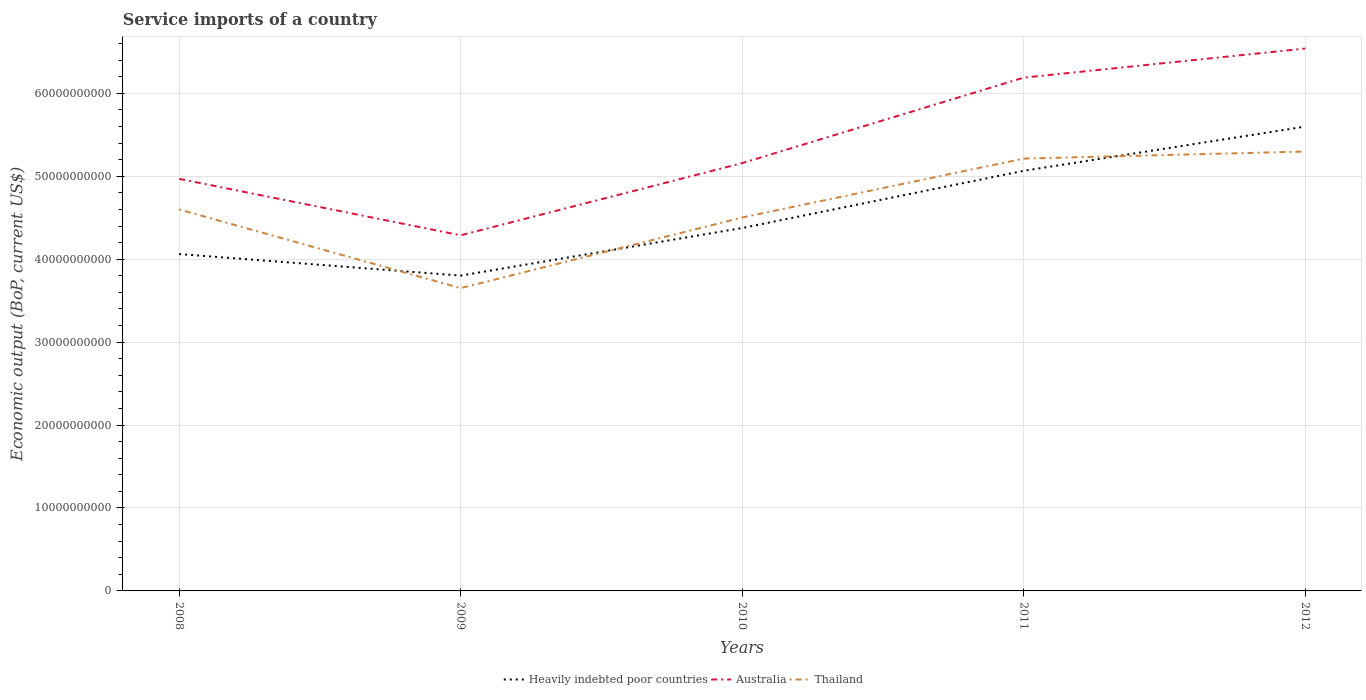How many different coloured lines are there?
Ensure brevity in your answer.  3. Does the line corresponding to Thailand intersect with the line corresponding to Heavily indebted poor countries?
Offer a terse response. Yes. Is the number of lines equal to the number of legend labels?
Your answer should be very brief. Yes. Across all years, what is the maximum service imports in Thailand?
Offer a very short reply. 3.65e+1. In which year was the service imports in Heavily indebted poor countries maximum?
Make the answer very short. 2009. What is the total service imports in Heavily indebted poor countries in the graph?
Give a very brief answer. -5.33e+09. What is the difference between the highest and the second highest service imports in Australia?
Make the answer very short. 2.25e+1. How many lines are there?
Give a very brief answer. 3. Are the values on the major ticks of Y-axis written in scientific E-notation?
Make the answer very short. No. Does the graph contain any zero values?
Give a very brief answer. No. Where does the legend appear in the graph?
Provide a short and direct response. Bottom center. How many legend labels are there?
Offer a terse response. 3. What is the title of the graph?
Keep it short and to the point. Service imports of a country. What is the label or title of the X-axis?
Provide a succinct answer. Years. What is the label or title of the Y-axis?
Keep it short and to the point. Economic output (BoP, current US$). What is the Economic output (BoP, current US$) in Heavily indebted poor countries in 2008?
Keep it short and to the point. 4.06e+1. What is the Economic output (BoP, current US$) in Australia in 2008?
Provide a short and direct response. 4.97e+1. What is the Economic output (BoP, current US$) of Thailand in 2008?
Keep it short and to the point. 4.60e+1. What is the Economic output (BoP, current US$) of Heavily indebted poor countries in 2009?
Your response must be concise. 3.80e+1. What is the Economic output (BoP, current US$) of Australia in 2009?
Offer a terse response. 4.29e+1. What is the Economic output (BoP, current US$) of Thailand in 2009?
Offer a terse response. 3.65e+1. What is the Economic output (BoP, current US$) of Heavily indebted poor countries in 2010?
Keep it short and to the point. 4.38e+1. What is the Economic output (BoP, current US$) of Australia in 2010?
Keep it short and to the point. 5.16e+1. What is the Economic output (BoP, current US$) of Thailand in 2010?
Provide a succinct answer. 4.50e+1. What is the Economic output (BoP, current US$) in Heavily indebted poor countries in 2011?
Ensure brevity in your answer.  5.07e+1. What is the Economic output (BoP, current US$) of Australia in 2011?
Give a very brief answer. 6.19e+1. What is the Economic output (BoP, current US$) of Thailand in 2011?
Provide a short and direct response. 5.21e+1. What is the Economic output (BoP, current US$) in Heavily indebted poor countries in 2012?
Keep it short and to the point. 5.60e+1. What is the Economic output (BoP, current US$) in Australia in 2012?
Your response must be concise. 6.54e+1. What is the Economic output (BoP, current US$) in Thailand in 2012?
Offer a very short reply. 5.30e+1. Across all years, what is the maximum Economic output (BoP, current US$) of Heavily indebted poor countries?
Your answer should be compact. 5.60e+1. Across all years, what is the maximum Economic output (BoP, current US$) in Australia?
Offer a very short reply. 6.54e+1. Across all years, what is the maximum Economic output (BoP, current US$) of Thailand?
Provide a succinct answer. 5.30e+1. Across all years, what is the minimum Economic output (BoP, current US$) of Heavily indebted poor countries?
Give a very brief answer. 3.80e+1. Across all years, what is the minimum Economic output (BoP, current US$) in Australia?
Keep it short and to the point. 4.29e+1. Across all years, what is the minimum Economic output (BoP, current US$) of Thailand?
Your response must be concise. 3.65e+1. What is the total Economic output (BoP, current US$) in Heavily indebted poor countries in the graph?
Your answer should be compact. 2.29e+11. What is the total Economic output (BoP, current US$) of Australia in the graph?
Your answer should be very brief. 2.71e+11. What is the total Economic output (BoP, current US$) of Thailand in the graph?
Offer a terse response. 2.33e+11. What is the difference between the Economic output (BoP, current US$) in Heavily indebted poor countries in 2008 and that in 2009?
Your response must be concise. 2.60e+09. What is the difference between the Economic output (BoP, current US$) of Australia in 2008 and that in 2009?
Your response must be concise. 6.80e+09. What is the difference between the Economic output (BoP, current US$) of Thailand in 2008 and that in 2009?
Offer a very short reply. 9.49e+09. What is the difference between the Economic output (BoP, current US$) of Heavily indebted poor countries in 2008 and that in 2010?
Ensure brevity in your answer.  -3.14e+09. What is the difference between the Economic output (BoP, current US$) of Australia in 2008 and that in 2010?
Offer a very short reply. -1.90e+09. What is the difference between the Economic output (BoP, current US$) in Thailand in 2008 and that in 2010?
Provide a short and direct response. 9.72e+08. What is the difference between the Economic output (BoP, current US$) of Heavily indebted poor countries in 2008 and that in 2011?
Offer a very short reply. -1.00e+1. What is the difference between the Economic output (BoP, current US$) of Australia in 2008 and that in 2011?
Offer a very short reply. -1.22e+1. What is the difference between the Economic output (BoP, current US$) in Thailand in 2008 and that in 2011?
Offer a very short reply. -6.13e+09. What is the difference between the Economic output (BoP, current US$) in Heavily indebted poor countries in 2008 and that in 2012?
Your answer should be compact. -1.54e+1. What is the difference between the Economic output (BoP, current US$) in Australia in 2008 and that in 2012?
Make the answer very short. -1.57e+1. What is the difference between the Economic output (BoP, current US$) of Thailand in 2008 and that in 2012?
Your answer should be compact. -6.98e+09. What is the difference between the Economic output (BoP, current US$) in Heavily indebted poor countries in 2009 and that in 2010?
Offer a very short reply. -5.74e+09. What is the difference between the Economic output (BoP, current US$) of Australia in 2009 and that in 2010?
Your response must be concise. -8.70e+09. What is the difference between the Economic output (BoP, current US$) in Thailand in 2009 and that in 2010?
Keep it short and to the point. -8.51e+09. What is the difference between the Economic output (BoP, current US$) of Heavily indebted poor countries in 2009 and that in 2011?
Your answer should be compact. -1.26e+1. What is the difference between the Economic output (BoP, current US$) of Australia in 2009 and that in 2011?
Make the answer very short. -1.90e+1. What is the difference between the Economic output (BoP, current US$) of Thailand in 2009 and that in 2011?
Keep it short and to the point. -1.56e+1. What is the difference between the Economic output (BoP, current US$) in Heavily indebted poor countries in 2009 and that in 2012?
Provide a succinct answer. -1.80e+1. What is the difference between the Economic output (BoP, current US$) in Australia in 2009 and that in 2012?
Make the answer very short. -2.25e+1. What is the difference between the Economic output (BoP, current US$) in Thailand in 2009 and that in 2012?
Your answer should be very brief. -1.65e+1. What is the difference between the Economic output (BoP, current US$) in Heavily indebted poor countries in 2010 and that in 2011?
Provide a short and direct response. -6.90e+09. What is the difference between the Economic output (BoP, current US$) of Australia in 2010 and that in 2011?
Your response must be concise. -1.03e+1. What is the difference between the Economic output (BoP, current US$) of Thailand in 2010 and that in 2011?
Your answer should be very brief. -7.11e+09. What is the difference between the Economic output (BoP, current US$) in Heavily indebted poor countries in 2010 and that in 2012?
Provide a succinct answer. -1.22e+1. What is the difference between the Economic output (BoP, current US$) in Australia in 2010 and that in 2012?
Make the answer very short. -1.38e+1. What is the difference between the Economic output (BoP, current US$) of Thailand in 2010 and that in 2012?
Provide a succinct answer. -7.96e+09. What is the difference between the Economic output (BoP, current US$) in Heavily indebted poor countries in 2011 and that in 2012?
Provide a succinct answer. -5.33e+09. What is the difference between the Economic output (BoP, current US$) of Australia in 2011 and that in 2012?
Offer a very short reply. -3.51e+09. What is the difference between the Economic output (BoP, current US$) in Thailand in 2011 and that in 2012?
Ensure brevity in your answer.  -8.51e+08. What is the difference between the Economic output (BoP, current US$) of Heavily indebted poor countries in 2008 and the Economic output (BoP, current US$) of Australia in 2009?
Provide a short and direct response. -2.26e+09. What is the difference between the Economic output (BoP, current US$) of Heavily indebted poor countries in 2008 and the Economic output (BoP, current US$) of Thailand in 2009?
Offer a terse response. 4.11e+09. What is the difference between the Economic output (BoP, current US$) in Australia in 2008 and the Economic output (BoP, current US$) in Thailand in 2009?
Provide a succinct answer. 1.32e+1. What is the difference between the Economic output (BoP, current US$) in Heavily indebted poor countries in 2008 and the Economic output (BoP, current US$) in Australia in 2010?
Ensure brevity in your answer.  -1.10e+1. What is the difference between the Economic output (BoP, current US$) of Heavily indebted poor countries in 2008 and the Economic output (BoP, current US$) of Thailand in 2010?
Ensure brevity in your answer.  -4.40e+09. What is the difference between the Economic output (BoP, current US$) of Australia in 2008 and the Economic output (BoP, current US$) of Thailand in 2010?
Offer a terse response. 4.66e+09. What is the difference between the Economic output (BoP, current US$) of Heavily indebted poor countries in 2008 and the Economic output (BoP, current US$) of Australia in 2011?
Give a very brief answer. -2.13e+1. What is the difference between the Economic output (BoP, current US$) of Heavily indebted poor countries in 2008 and the Economic output (BoP, current US$) of Thailand in 2011?
Your response must be concise. -1.15e+1. What is the difference between the Economic output (BoP, current US$) in Australia in 2008 and the Economic output (BoP, current US$) in Thailand in 2011?
Your answer should be compact. -2.44e+09. What is the difference between the Economic output (BoP, current US$) of Heavily indebted poor countries in 2008 and the Economic output (BoP, current US$) of Australia in 2012?
Your answer should be very brief. -2.48e+1. What is the difference between the Economic output (BoP, current US$) in Heavily indebted poor countries in 2008 and the Economic output (BoP, current US$) in Thailand in 2012?
Give a very brief answer. -1.24e+1. What is the difference between the Economic output (BoP, current US$) of Australia in 2008 and the Economic output (BoP, current US$) of Thailand in 2012?
Give a very brief answer. -3.29e+09. What is the difference between the Economic output (BoP, current US$) in Heavily indebted poor countries in 2009 and the Economic output (BoP, current US$) in Australia in 2010?
Make the answer very short. -1.36e+1. What is the difference between the Economic output (BoP, current US$) of Heavily indebted poor countries in 2009 and the Economic output (BoP, current US$) of Thailand in 2010?
Keep it short and to the point. -7.00e+09. What is the difference between the Economic output (BoP, current US$) of Australia in 2009 and the Economic output (BoP, current US$) of Thailand in 2010?
Your response must be concise. -2.14e+09. What is the difference between the Economic output (BoP, current US$) of Heavily indebted poor countries in 2009 and the Economic output (BoP, current US$) of Australia in 2011?
Give a very brief answer. -2.39e+1. What is the difference between the Economic output (BoP, current US$) of Heavily indebted poor countries in 2009 and the Economic output (BoP, current US$) of Thailand in 2011?
Keep it short and to the point. -1.41e+1. What is the difference between the Economic output (BoP, current US$) of Australia in 2009 and the Economic output (BoP, current US$) of Thailand in 2011?
Your answer should be very brief. -9.25e+09. What is the difference between the Economic output (BoP, current US$) of Heavily indebted poor countries in 2009 and the Economic output (BoP, current US$) of Australia in 2012?
Provide a short and direct response. -2.74e+1. What is the difference between the Economic output (BoP, current US$) in Heavily indebted poor countries in 2009 and the Economic output (BoP, current US$) in Thailand in 2012?
Your answer should be very brief. -1.50e+1. What is the difference between the Economic output (BoP, current US$) in Australia in 2009 and the Economic output (BoP, current US$) in Thailand in 2012?
Keep it short and to the point. -1.01e+1. What is the difference between the Economic output (BoP, current US$) of Heavily indebted poor countries in 2010 and the Economic output (BoP, current US$) of Australia in 2011?
Keep it short and to the point. -1.81e+1. What is the difference between the Economic output (BoP, current US$) in Heavily indebted poor countries in 2010 and the Economic output (BoP, current US$) in Thailand in 2011?
Make the answer very short. -8.37e+09. What is the difference between the Economic output (BoP, current US$) of Australia in 2010 and the Economic output (BoP, current US$) of Thailand in 2011?
Your answer should be compact. -5.46e+08. What is the difference between the Economic output (BoP, current US$) of Heavily indebted poor countries in 2010 and the Economic output (BoP, current US$) of Australia in 2012?
Give a very brief answer. -2.16e+1. What is the difference between the Economic output (BoP, current US$) in Heavily indebted poor countries in 2010 and the Economic output (BoP, current US$) in Thailand in 2012?
Offer a very short reply. -9.22e+09. What is the difference between the Economic output (BoP, current US$) of Australia in 2010 and the Economic output (BoP, current US$) of Thailand in 2012?
Offer a terse response. -1.40e+09. What is the difference between the Economic output (BoP, current US$) in Heavily indebted poor countries in 2011 and the Economic output (BoP, current US$) in Australia in 2012?
Ensure brevity in your answer.  -1.47e+1. What is the difference between the Economic output (BoP, current US$) in Heavily indebted poor countries in 2011 and the Economic output (BoP, current US$) in Thailand in 2012?
Your answer should be very brief. -2.32e+09. What is the difference between the Economic output (BoP, current US$) of Australia in 2011 and the Economic output (BoP, current US$) of Thailand in 2012?
Your answer should be compact. 8.91e+09. What is the average Economic output (BoP, current US$) of Heavily indebted poor countries per year?
Your answer should be compact. 4.58e+1. What is the average Economic output (BoP, current US$) in Australia per year?
Your answer should be very brief. 5.43e+1. What is the average Economic output (BoP, current US$) of Thailand per year?
Ensure brevity in your answer.  4.65e+1. In the year 2008, what is the difference between the Economic output (BoP, current US$) in Heavily indebted poor countries and Economic output (BoP, current US$) in Australia?
Give a very brief answer. -9.07e+09. In the year 2008, what is the difference between the Economic output (BoP, current US$) of Heavily indebted poor countries and Economic output (BoP, current US$) of Thailand?
Your answer should be very brief. -5.38e+09. In the year 2008, what is the difference between the Economic output (BoP, current US$) of Australia and Economic output (BoP, current US$) of Thailand?
Provide a succinct answer. 3.69e+09. In the year 2009, what is the difference between the Economic output (BoP, current US$) in Heavily indebted poor countries and Economic output (BoP, current US$) in Australia?
Your answer should be very brief. -4.86e+09. In the year 2009, what is the difference between the Economic output (BoP, current US$) in Heavily indebted poor countries and Economic output (BoP, current US$) in Thailand?
Keep it short and to the point. 1.51e+09. In the year 2009, what is the difference between the Economic output (BoP, current US$) in Australia and Economic output (BoP, current US$) in Thailand?
Your answer should be very brief. 6.37e+09. In the year 2010, what is the difference between the Economic output (BoP, current US$) in Heavily indebted poor countries and Economic output (BoP, current US$) in Australia?
Provide a short and direct response. -7.83e+09. In the year 2010, what is the difference between the Economic output (BoP, current US$) of Heavily indebted poor countries and Economic output (BoP, current US$) of Thailand?
Your answer should be very brief. -1.27e+09. In the year 2010, what is the difference between the Economic output (BoP, current US$) of Australia and Economic output (BoP, current US$) of Thailand?
Give a very brief answer. 6.56e+09. In the year 2011, what is the difference between the Economic output (BoP, current US$) in Heavily indebted poor countries and Economic output (BoP, current US$) in Australia?
Offer a very short reply. -1.12e+1. In the year 2011, what is the difference between the Economic output (BoP, current US$) of Heavily indebted poor countries and Economic output (BoP, current US$) of Thailand?
Give a very brief answer. -1.47e+09. In the year 2011, what is the difference between the Economic output (BoP, current US$) in Australia and Economic output (BoP, current US$) in Thailand?
Your response must be concise. 9.76e+09. In the year 2012, what is the difference between the Economic output (BoP, current US$) in Heavily indebted poor countries and Economic output (BoP, current US$) in Australia?
Provide a succinct answer. -9.41e+09. In the year 2012, what is the difference between the Economic output (BoP, current US$) in Heavily indebted poor countries and Economic output (BoP, current US$) in Thailand?
Your answer should be very brief. 3.01e+09. In the year 2012, what is the difference between the Economic output (BoP, current US$) of Australia and Economic output (BoP, current US$) of Thailand?
Give a very brief answer. 1.24e+1. What is the ratio of the Economic output (BoP, current US$) in Heavily indebted poor countries in 2008 to that in 2009?
Ensure brevity in your answer.  1.07. What is the ratio of the Economic output (BoP, current US$) in Australia in 2008 to that in 2009?
Your response must be concise. 1.16. What is the ratio of the Economic output (BoP, current US$) of Thailand in 2008 to that in 2009?
Make the answer very short. 1.26. What is the ratio of the Economic output (BoP, current US$) in Heavily indebted poor countries in 2008 to that in 2010?
Provide a succinct answer. 0.93. What is the ratio of the Economic output (BoP, current US$) of Australia in 2008 to that in 2010?
Your answer should be very brief. 0.96. What is the ratio of the Economic output (BoP, current US$) of Thailand in 2008 to that in 2010?
Provide a short and direct response. 1.02. What is the ratio of the Economic output (BoP, current US$) of Heavily indebted poor countries in 2008 to that in 2011?
Your answer should be compact. 0.8. What is the ratio of the Economic output (BoP, current US$) of Australia in 2008 to that in 2011?
Provide a short and direct response. 0.8. What is the ratio of the Economic output (BoP, current US$) in Thailand in 2008 to that in 2011?
Provide a succinct answer. 0.88. What is the ratio of the Economic output (BoP, current US$) in Heavily indebted poor countries in 2008 to that in 2012?
Provide a succinct answer. 0.73. What is the ratio of the Economic output (BoP, current US$) in Australia in 2008 to that in 2012?
Your response must be concise. 0.76. What is the ratio of the Economic output (BoP, current US$) of Thailand in 2008 to that in 2012?
Provide a short and direct response. 0.87. What is the ratio of the Economic output (BoP, current US$) in Heavily indebted poor countries in 2009 to that in 2010?
Offer a terse response. 0.87. What is the ratio of the Economic output (BoP, current US$) in Australia in 2009 to that in 2010?
Give a very brief answer. 0.83. What is the ratio of the Economic output (BoP, current US$) in Thailand in 2009 to that in 2010?
Ensure brevity in your answer.  0.81. What is the ratio of the Economic output (BoP, current US$) of Heavily indebted poor countries in 2009 to that in 2011?
Give a very brief answer. 0.75. What is the ratio of the Economic output (BoP, current US$) of Australia in 2009 to that in 2011?
Ensure brevity in your answer.  0.69. What is the ratio of the Economic output (BoP, current US$) in Thailand in 2009 to that in 2011?
Offer a terse response. 0.7. What is the ratio of the Economic output (BoP, current US$) of Heavily indebted poor countries in 2009 to that in 2012?
Provide a short and direct response. 0.68. What is the ratio of the Economic output (BoP, current US$) of Australia in 2009 to that in 2012?
Keep it short and to the point. 0.66. What is the ratio of the Economic output (BoP, current US$) of Thailand in 2009 to that in 2012?
Make the answer very short. 0.69. What is the ratio of the Economic output (BoP, current US$) in Heavily indebted poor countries in 2010 to that in 2011?
Provide a succinct answer. 0.86. What is the ratio of the Economic output (BoP, current US$) of Australia in 2010 to that in 2011?
Your answer should be compact. 0.83. What is the ratio of the Economic output (BoP, current US$) of Thailand in 2010 to that in 2011?
Provide a succinct answer. 0.86. What is the ratio of the Economic output (BoP, current US$) of Heavily indebted poor countries in 2010 to that in 2012?
Your response must be concise. 0.78. What is the ratio of the Economic output (BoP, current US$) in Australia in 2010 to that in 2012?
Make the answer very short. 0.79. What is the ratio of the Economic output (BoP, current US$) of Thailand in 2010 to that in 2012?
Your answer should be compact. 0.85. What is the ratio of the Economic output (BoP, current US$) in Heavily indebted poor countries in 2011 to that in 2012?
Make the answer very short. 0.9. What is the ratio of the Economic output (BoP, current US$) in Australia in 2011 to that in 2012?
Keep it short and to the point. 0.95. What is the ratio of the Economic output (BoP, current US$) of Thailand in 2011 to that in 2012?
Give a very brief answer. 0.98. What is the difference between the highest and the second highest Economic output (BoP, current US$) of Heavily indebted poor countries?
Offer a terse response. 5.33e+09. What is the difference between the highest and the second highest Economic output (BoP, current US$) in Australia?
Provide a short and direct response. 3.51e+09. What is the difference between the highest and the second highest Economic output (BoP, current US$) in Thailand?
Offer a terse response. 8.51e+08. What is the difference between the highest and the lowest Economic output (BoP, current US$) of Heavily indebted poor countries?
Ensure brevity in your answer.  1.80e+1. What is the difference between the highest and the lowest Economic output (BoP, current US$) of Australia?
Offer a terse response. 2.25e+1. What is the difference between the highest and the lowest Economic output (BoP, current US$) of Thailand?
Make the answer very short. 1.65e+1. 